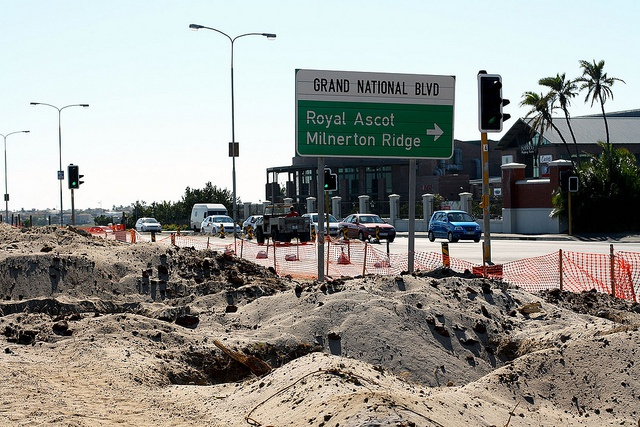Describe the objects in this image and their specific colors. I can see truck in lightblue, black, gray, maroon, and purple tones, car in lightblue, black, navy, blue, and gray tones, traffic light in lightblue, black, gray, and darkgray tones, car in lightblue, black, gray, lightgray, and darkgray tones, and truck in lightblue, darkgray, black, gray, and white tones in this image. 